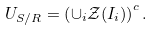Convert formula to latex. <formula><loc_0><loc_0><loc_500><loc_500>U _ { S / R } = \left ( \cup _ { i } \mathcal { Z } ( I _ { i } ) \right ) ^ { c } .</formula> 